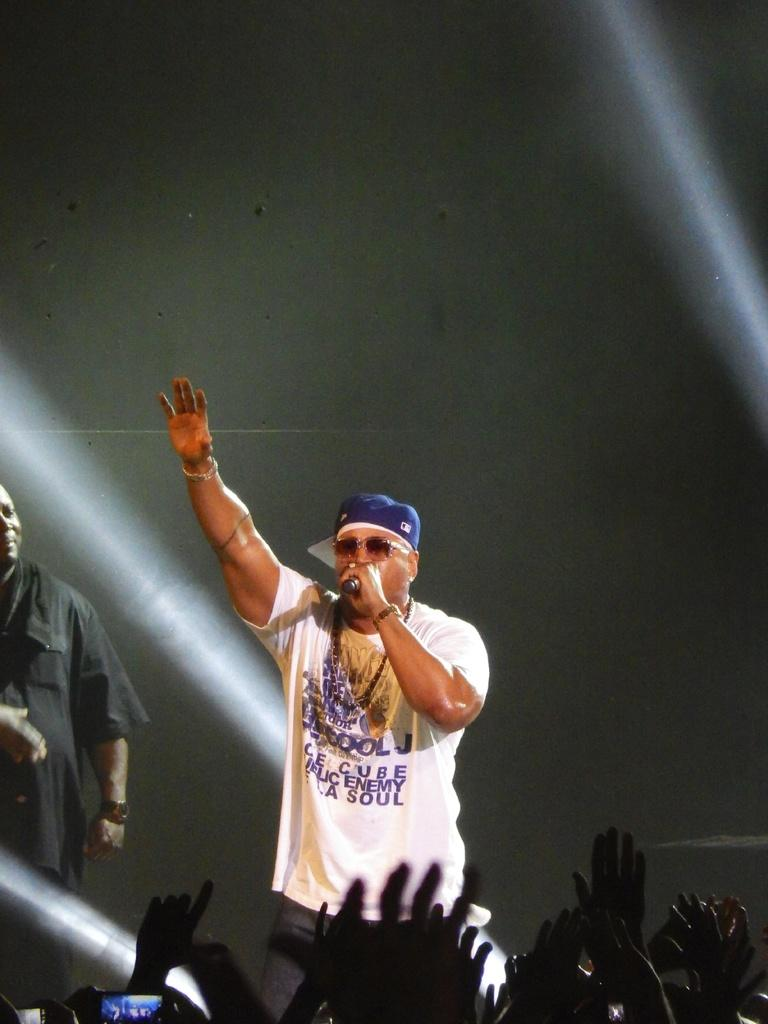Provide a one-sentence caption for the provided image. the singer is wearing a white tshirt with words like enemy and soul on it. 